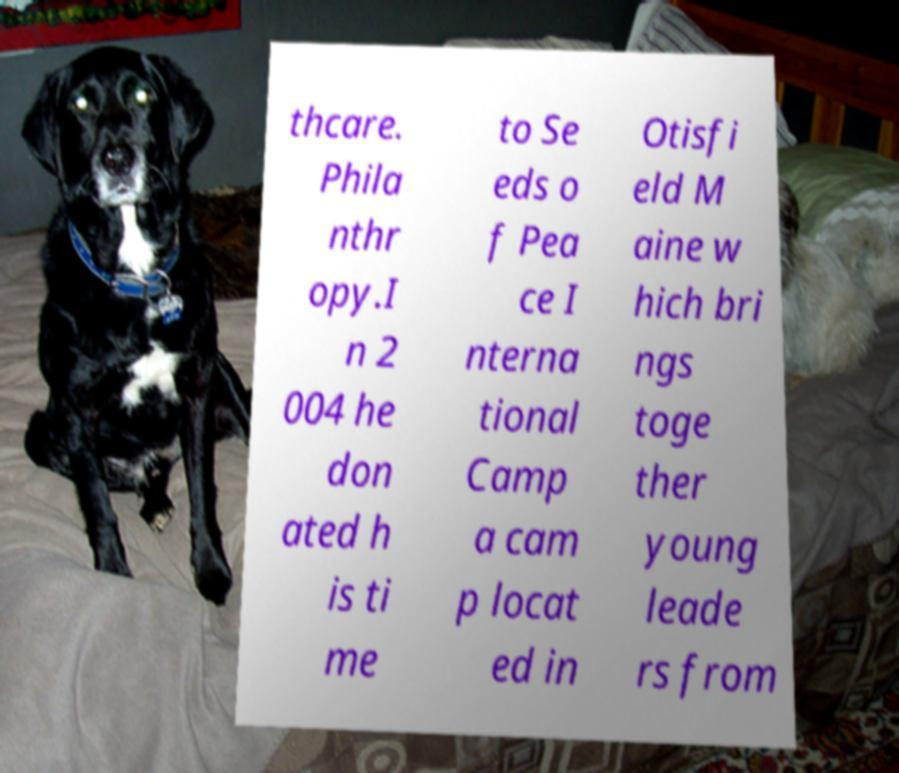Could you assist in decoding the text presented in this image and type it out clearly? thcare. Phila nthr opy.I n 2 004 he don ated h is ti me to Se eds o f Pea ce I nterna tional Camp a cam p locat ed in Otisfi eld M aine w hich bri ngs toge ther young leade rs from 